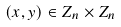<formula> <loc_0><loc_0><loc_500><loc_500>( x , y ) \in Z _ { n } \times Z _ { n }</formula> 